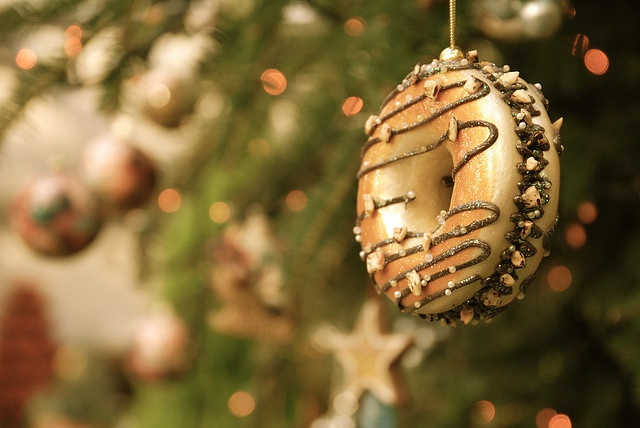Describe the objects in this image and their specific colors. I can see a donut in tan and olive tones in this image. 